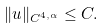Convert formula to latex. <formula><loc_0><loc_0><loc_500><loc_500>\| u \| _ { C ^ { 4 , \alpha } } \leq C .</formula> 